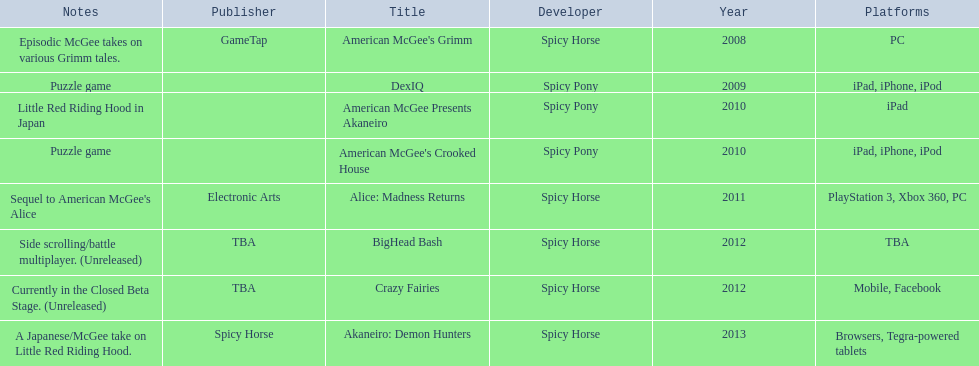What was the only game published by electronic arts? Alice: Madness Returns. 